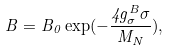<formula> <loc_0><loc_0><loc_500><loc_500>B = B _ { 0 } \exp ( - \frac { 4 g _ { \sigma } ^ { B } \sigma } { M _ { N } } ) ,</formula> 